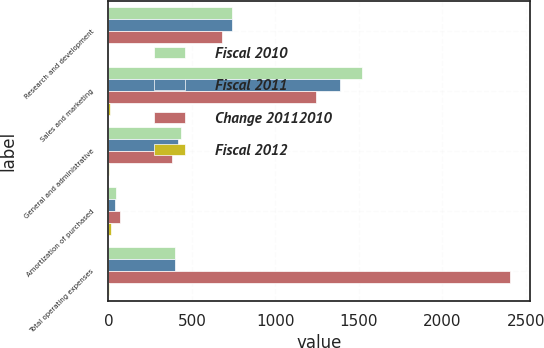<chart> <loc_0><loc_0><loc_500><loc_500><stacked_bar_chart><ecel><fcel>Research and development<fcel>Sales and marketing<fcel>General and administrative<fcel>Amortization of purchased<fcel>Total operating expenses<nl><fcel>Fiscal 2010<fcel>742.8<fcel>1516.1<fcel>435<fcel>48.7<fcel>399.05<nl><fcel>Fiscal 2011<fcel>738.1<fcel>1385.8<fcel>414.6<fcel>42.8<fcel>399.05<nl><fcel>Change 20112010<fcel>680.3<fcel>1244.2<fcel>383.5<fcel>72.1<fcel>2403.4<nl><fcel>Fiscal 2012<fcel>1<fcel>9<fcel>5<fcel>14<fcel>2<nl></chart> 